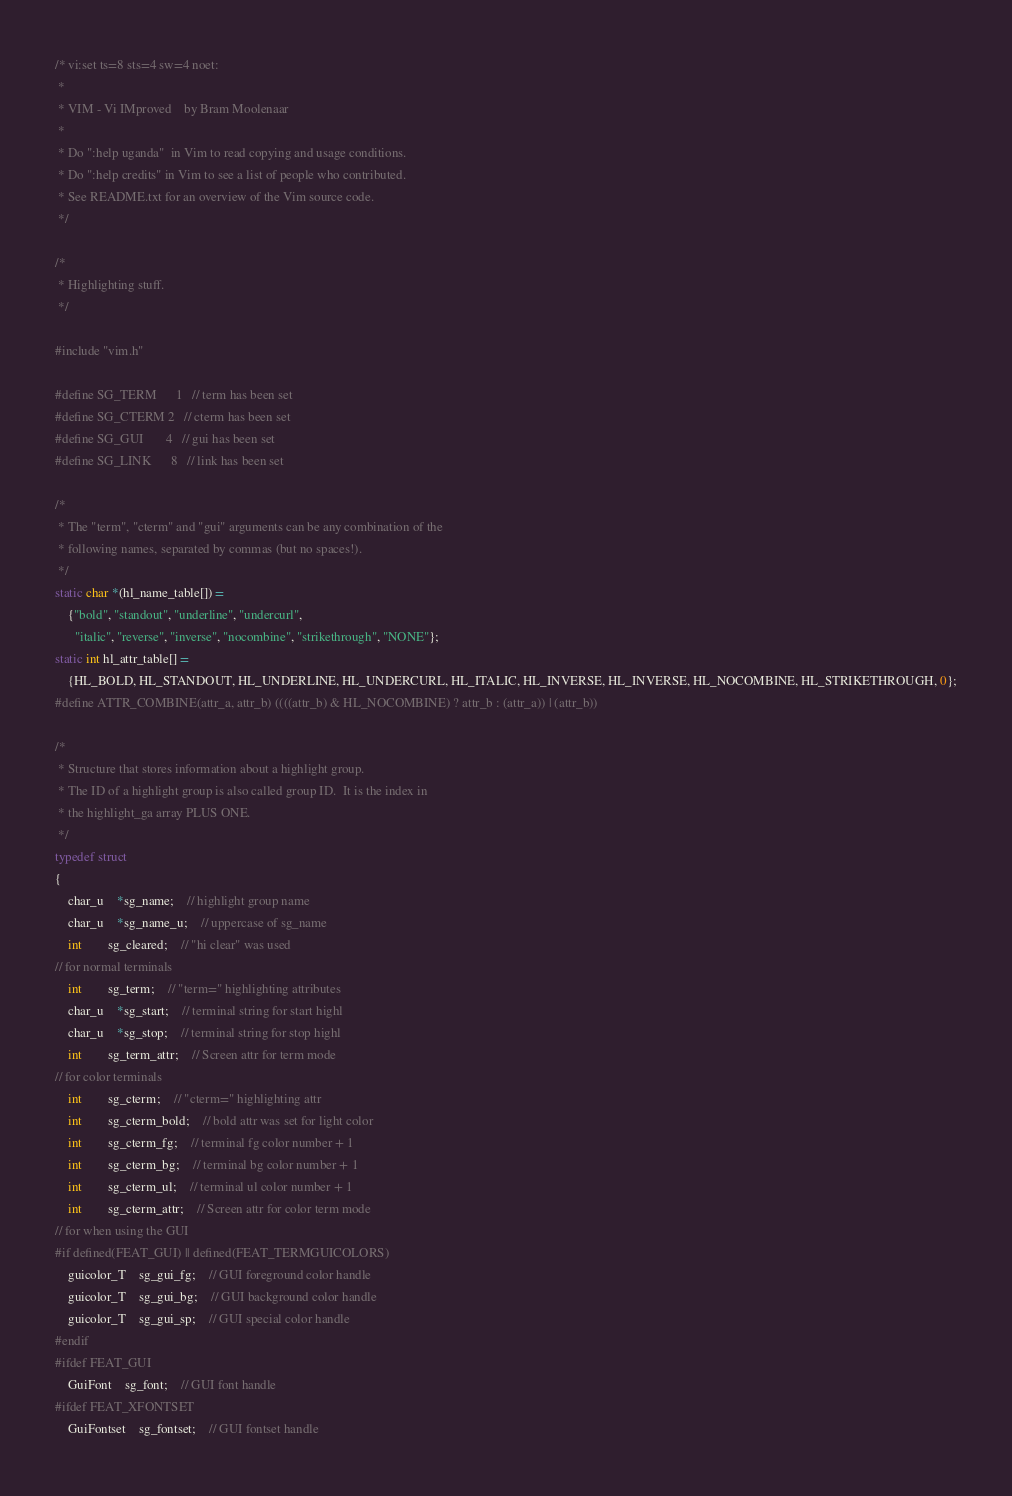<code> <loc_0><loc_0><loc_500><loc_500><_C_>/* vi:set ts=8 sts=4 sw=4 noet:
 *
 * VIM - Vi IMproved	by Bram Moolenaar
 *
 * Do ":help uganda"  in Vim to read copying and usage conditions.
 * Do ":help credits" in Vim to see a list of people who contributed.
 * See README.txt for an overview of the Vim source code.
 */

/*
 * Highlighting stuff.
 */

#include "vim.h"

#define SG_TERM		1	// term has been set
#define SG_CTERM	2	// cterm has been set
#define SG_GUI		4	// gui has been set
#define SG_LINK		8	// link has been set

/*
 * The "term", "cterm" and "gui" arguments can be any combination of the
 * following names, separated by commas (but no spaces!).
 */
static char *(hl_name_table[]) =
    {"bold", "standout", "underline", "undercurl",
      "italic", "reverse", "inverse", "nocombine", "strikethrough", "NONE"};
static int hl_attr_table[] =
    {HL_BOLD, HL_STANDOUT, HL_UNDERLINE, HL_UNDERCURL, HL_ITALIC, HL_INVERSE, HL_INVERSE, HL_NOCOMBINE, HL_STRIKETHROUGH, 0};
#define ATTR_COMBINE(attr_a, attr_b) ((((attr_b) & HL_NOCOMBINE) ? attr_b : (attr_a)) | (attr_b))

/*
 * Structure that stores information about a highlight group.
 * The ID of a highlight group is also called group ID.  It is the index in
 * the highlight_ga array PLUS ONE.
 */
typedef struct
{
    char_u	*sg_name;	// highlight group name
    char_u	*sg_name_u;	// uppercase of sg_name
    int		sg_cleared;	// "hi clear" was used
// for normal terminals
    int		sg_term;	// "term=" highlighting attributes
    char_u	*sg_start;	// terminal string for start highl
    char_u	*sg_stop;	// terminal string for stop highl
    int		sg_term_attr;	// Screen attr for term mode
// for color terminals
    int		sg_cterm;	// "cterm=" highlighting attr
    int		sg_cterm_bold;	// bold attr was set for light color
    int		sg_cterm_fg;	// terminal fg color number + 1
    int		sg_cterm_bg;	// terminal bg color number + 1
    int		sg_cterm_ul;	// terminal ul color number + 1
    int		sg_cterm_attr;	// Screen attr for color term mode
// for when using the GUI
#if defined(FEAT_GUI) || defined(FEAT_TERMGUICOLORS)
    guicolor_T	sg_gui_fg;	// GUI foreground color handle
    guicolor_T	sg_gui_bg;	// GUI background color handle
    guicolor_T	sg_gui_sp;	// GUI special color handle
#endif
#ifdef FEAT_GUI
    GuiFont	sg_font;	// GUI font handle
#ifdef FEAT_XFONTSET
    GuiFontset	sg_fontset;	// GUI fontset handle</code> 